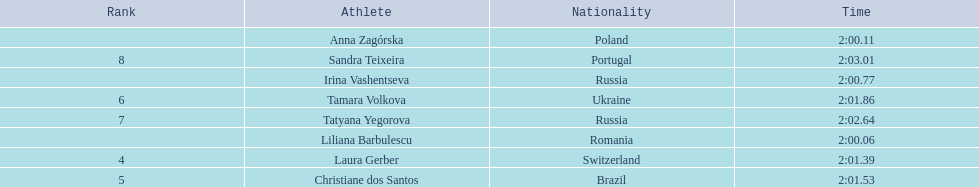How many runners finished with their time below 2:01? 3. 